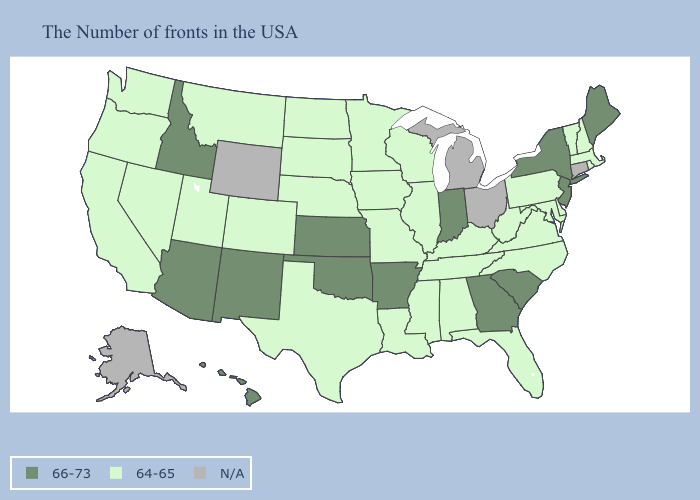Name the states that have a value in the range 66-73?
Write a very short answer. Maine, New York, New Jersey, South Carolina, Georgia, Indiana, Arkansas, Kansas, Oklahoma, New Mexico, Arizona, Idaho, Hawaii. Among the states that border Wyoming , does Idaho have the lowest value?
Write a very short answer. No. What is the value of Montana?
Quick response, please. 64-65. Does the first symbol in the legend represent the smallest category?
Answer briefly. No. Among the states that border Vermont , does New York have the lowest value?
Short answer required. No. What is the value of Oklahoma?
Give a very brief answer. 66-73. What is the value of California?
Short answer required. 64-65. Does Illinois have the highest value in the USA?
Concise answer only. No. Name the states that have a value in the range N/A?
Answer briefly. Connecticut, Ohio, Michigan, Wyoming, Alaska. Does the map have missing data?
Short answer required. Yes. Which states have the lowest value in the Northeast?
Keep it brief. Massachusetts, Rhode Island, New Hampshire, Vermont, Pennsylvania. Is the legend a continuous bar?
Give a very brief answer. No. What is the value of New Jersey?
Keep it brief. 66-73. 